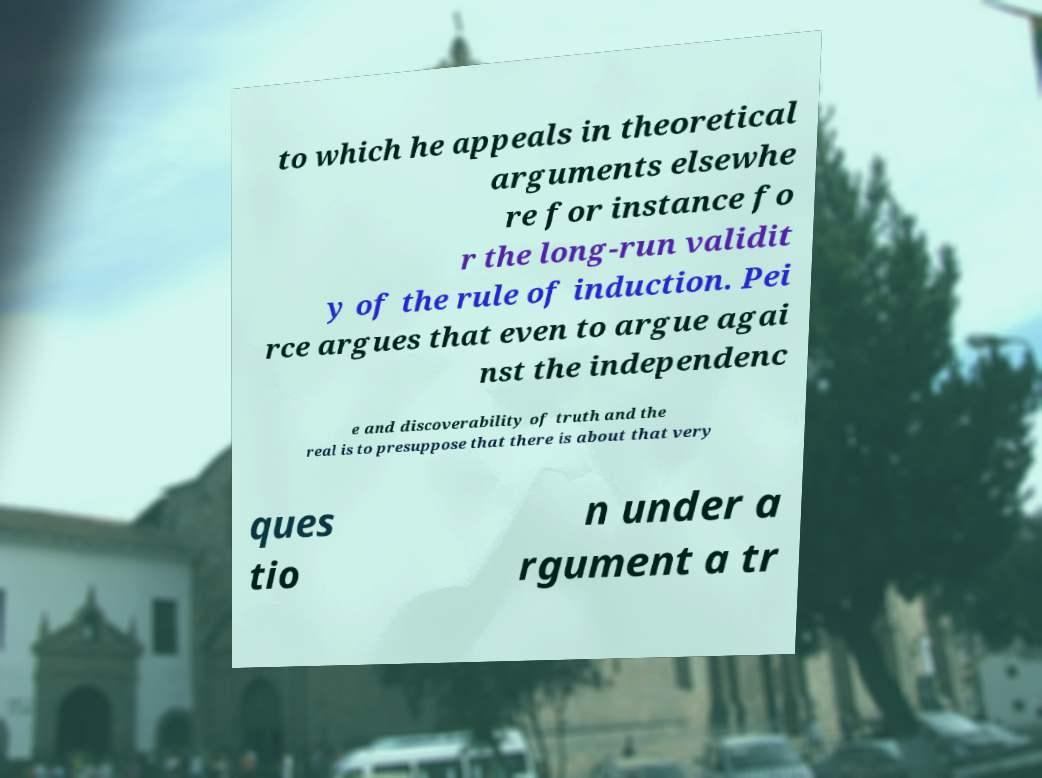For documentation purposes, I need the text within this image transcribed. Could you provide that? to which he appeals in theoretical arguments elsewhe re for instance fo r the long-run validit y of the rule of induction. Pei rce argues that even to argue agai nst the independenc e and discoverability of truth and the real is to presuppose that there is about that very ques tio n under a rgument a tr 